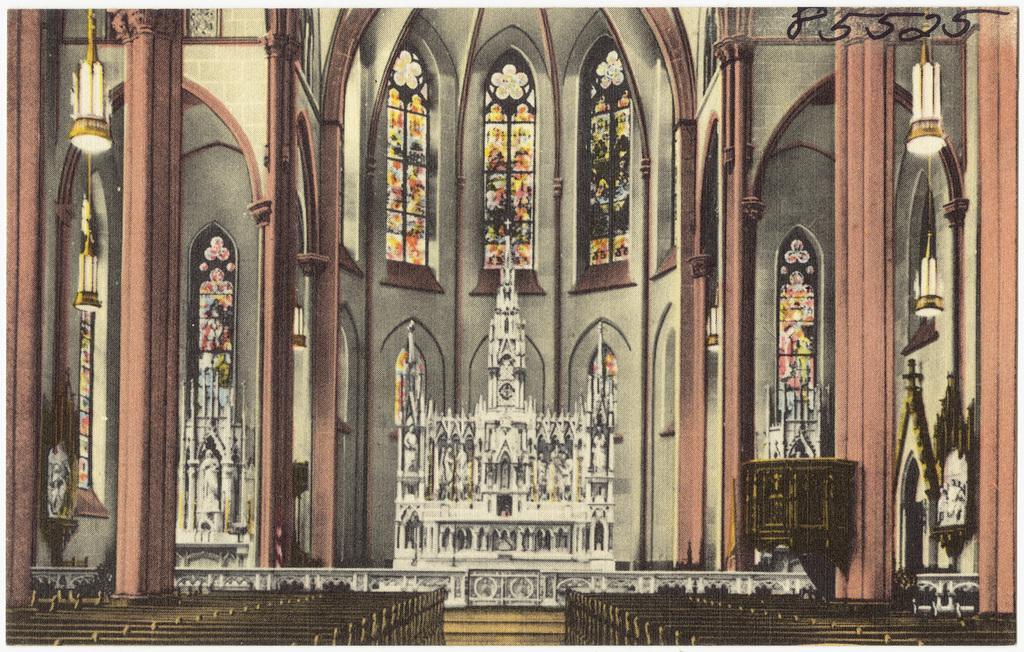Could you give a brief overview of what you see in this image? This is an edited image. This image consists of an inside view of a church. At the bottom there are some benches. Here I can see few pillars. In the background there is a wall along with the windows. 